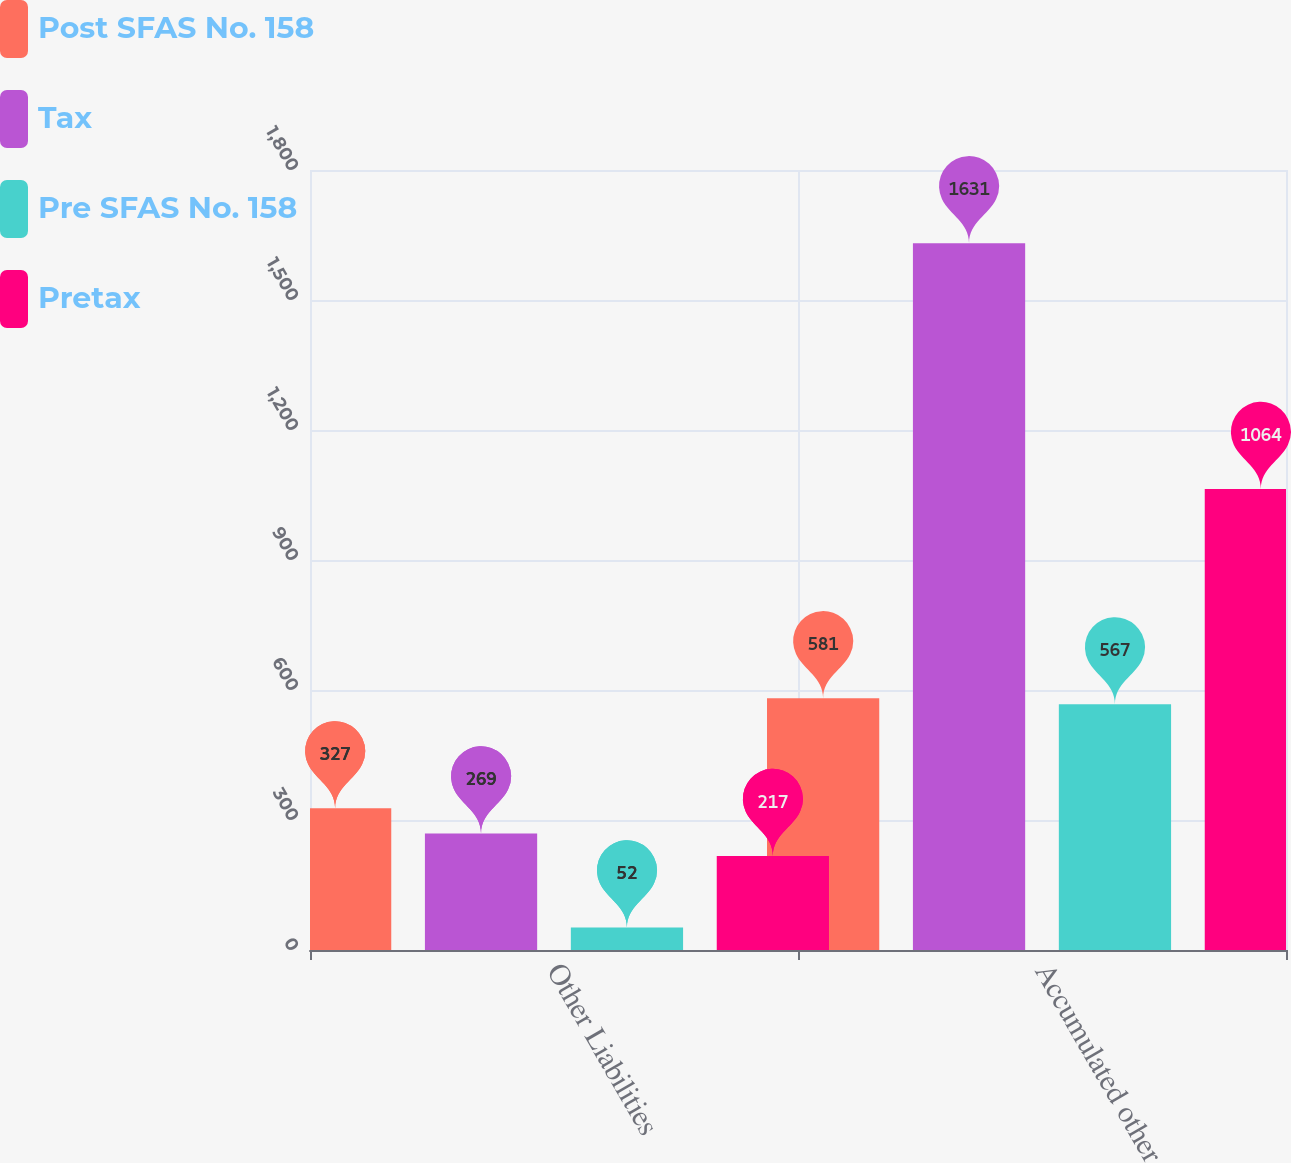Convert chart to OTSL. <chart><loc_0><loc_0><loc_500><loc_500><stacked_bar_chart><ecel><fcel>Other Liabilities<fcel>Accumulated other<nl><fcel>Post SFAS No. 158<fcel>327<fcel>581<nl><fcel>Tax<fcel>269<fcel>1631<nl><fcel>Pre SFAS No. 158<fcel>52<fcel>567<nl><fcel>Pretax<fcel>217<fcel>1064<nl></chart> 